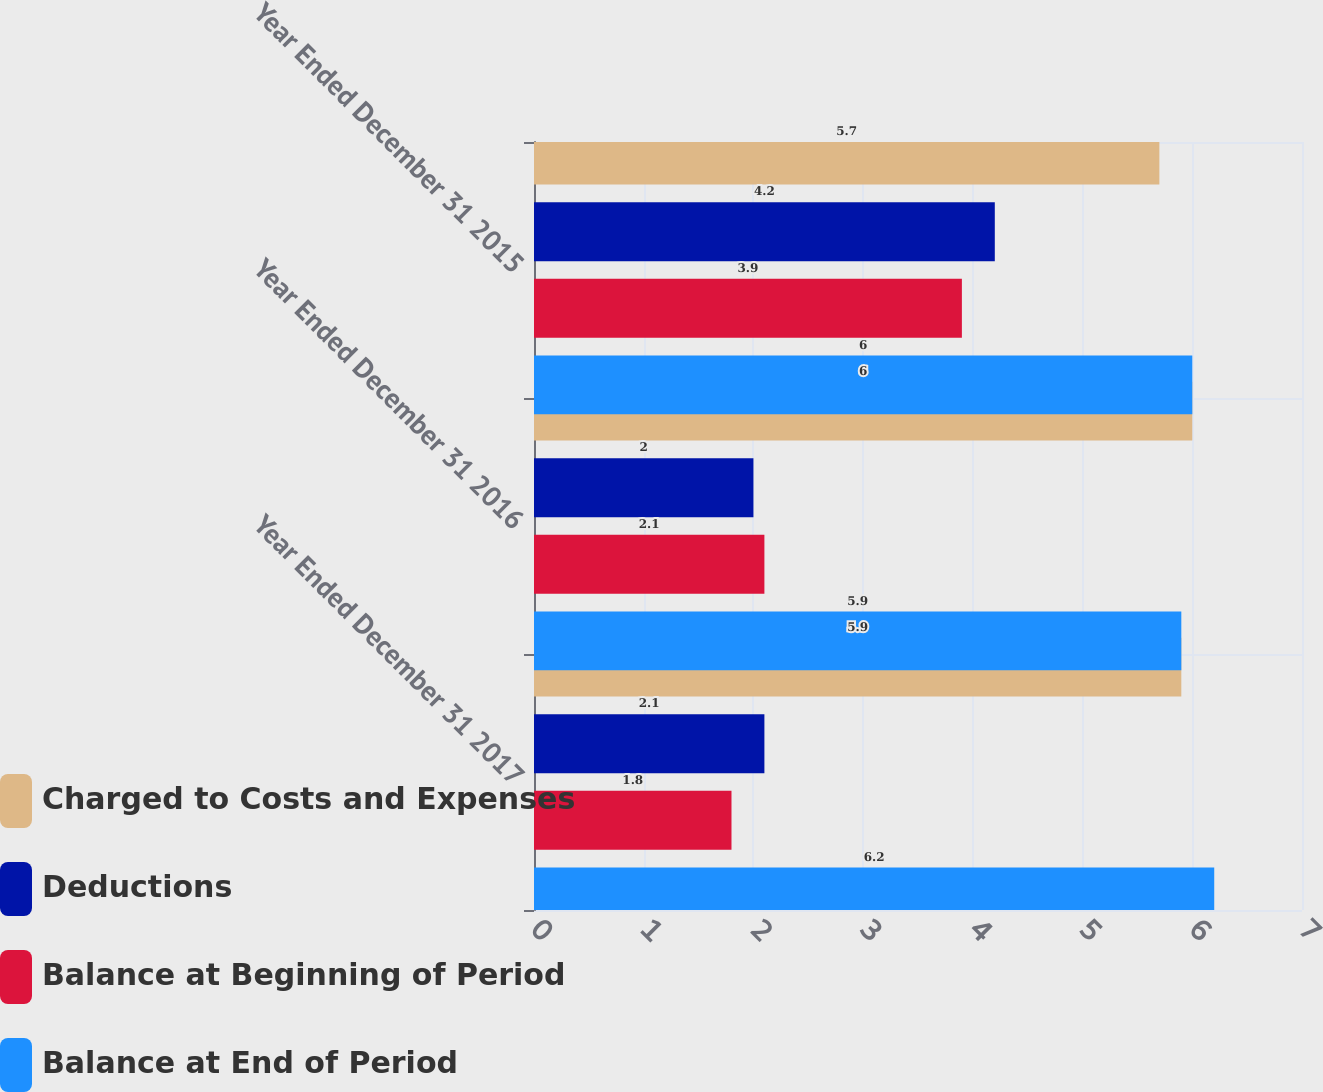Convert chart to OTSL. <chart><loc_0><loc_0><loc_500><loc_500><stacked_bar_chart><ecel><fcel>Year Ended December 31 2017<fcel>Year Ended December 31 2016<fcel>Year Ended December 31 2015<nl><fcel>Charged to Costs and Expenses<fcel>5.9<fcel>6<fcel>5.7<nl><fcel>Deductions<fcel>2.1<fcel>2<fcel>4.2<nl><fcel>Balance at Beginning of Period<fcel>1.8<fcel>2.1<fcel>3.9<nl><fcel>Balance at End of Period<fcel>6.2<fcel>5.9<fcel>6<nl></chart> 